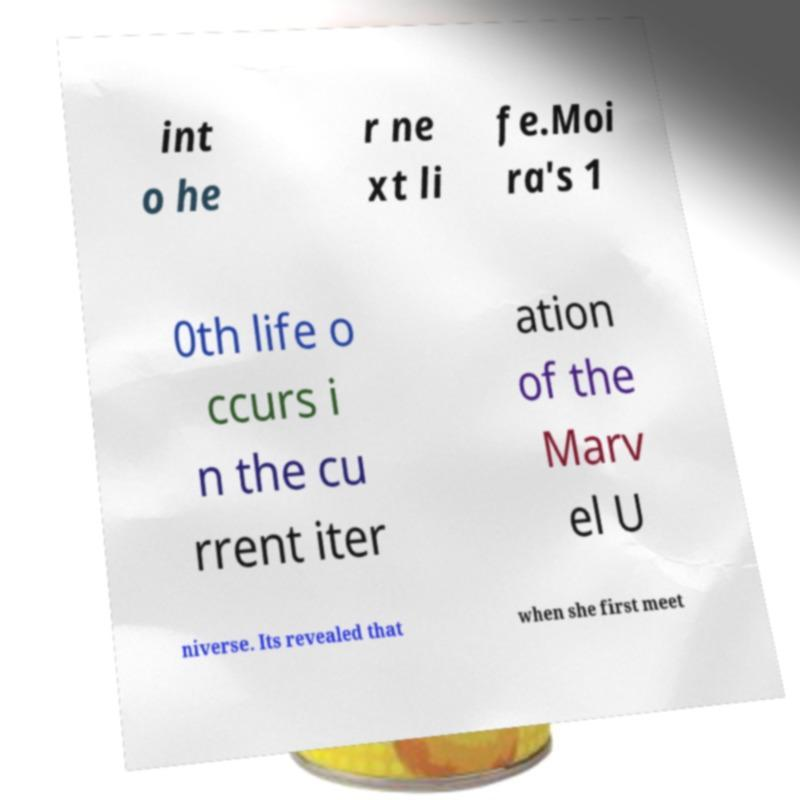What messages or text are displayed in this image? I need them in a readable, typed format. int o he r ne xt li fe.Moi ra's 1 0th life o ccurs i n the cu rrent iter ation of the Marv el U niverse. Its revealed that when she first meet 